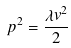<formula> <loc_0><loc_0><loc_500><loc_500>p ^ { 2 } = \frac { \lambda v ^ { 2 } } { 2 }</formula> 